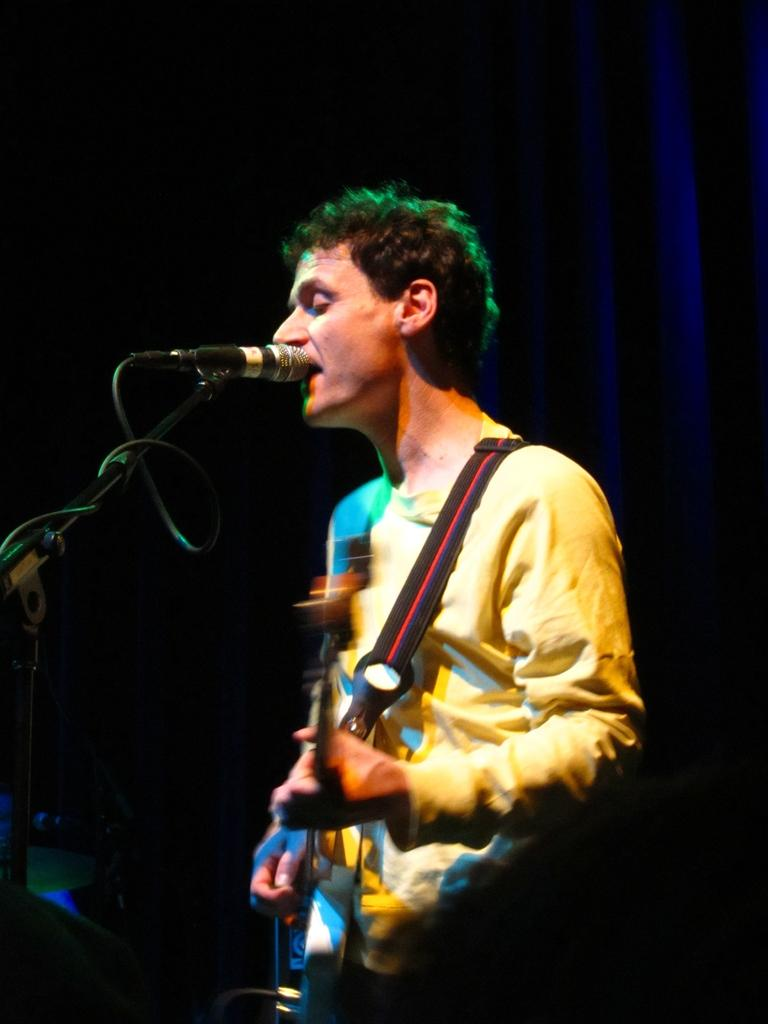What is the person in the image doing? The person in the image is holding a guitar. What object is present in the image that is commonly used for amplifying sound? There is a microphone in the image. What type of oatmeal is being served at the feast in the image? There is no feast or oatmeal present in the image; it features a person holding a guitar and a microphone. How many wheels can be seen on the vehicle in the image? There is no vehicle or wheel present in the image. 